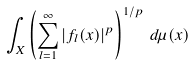Convert formula to latex. <formula><loc_0><loc_0><loc_500><loc_500>\int _ { X } \left ( \sum _ { l = 1 } ^ { \infty } | f _ { l } ( x ) | ^ { p } \right ) ^ { 1 / p } \, d \mu ( x )</formula> 